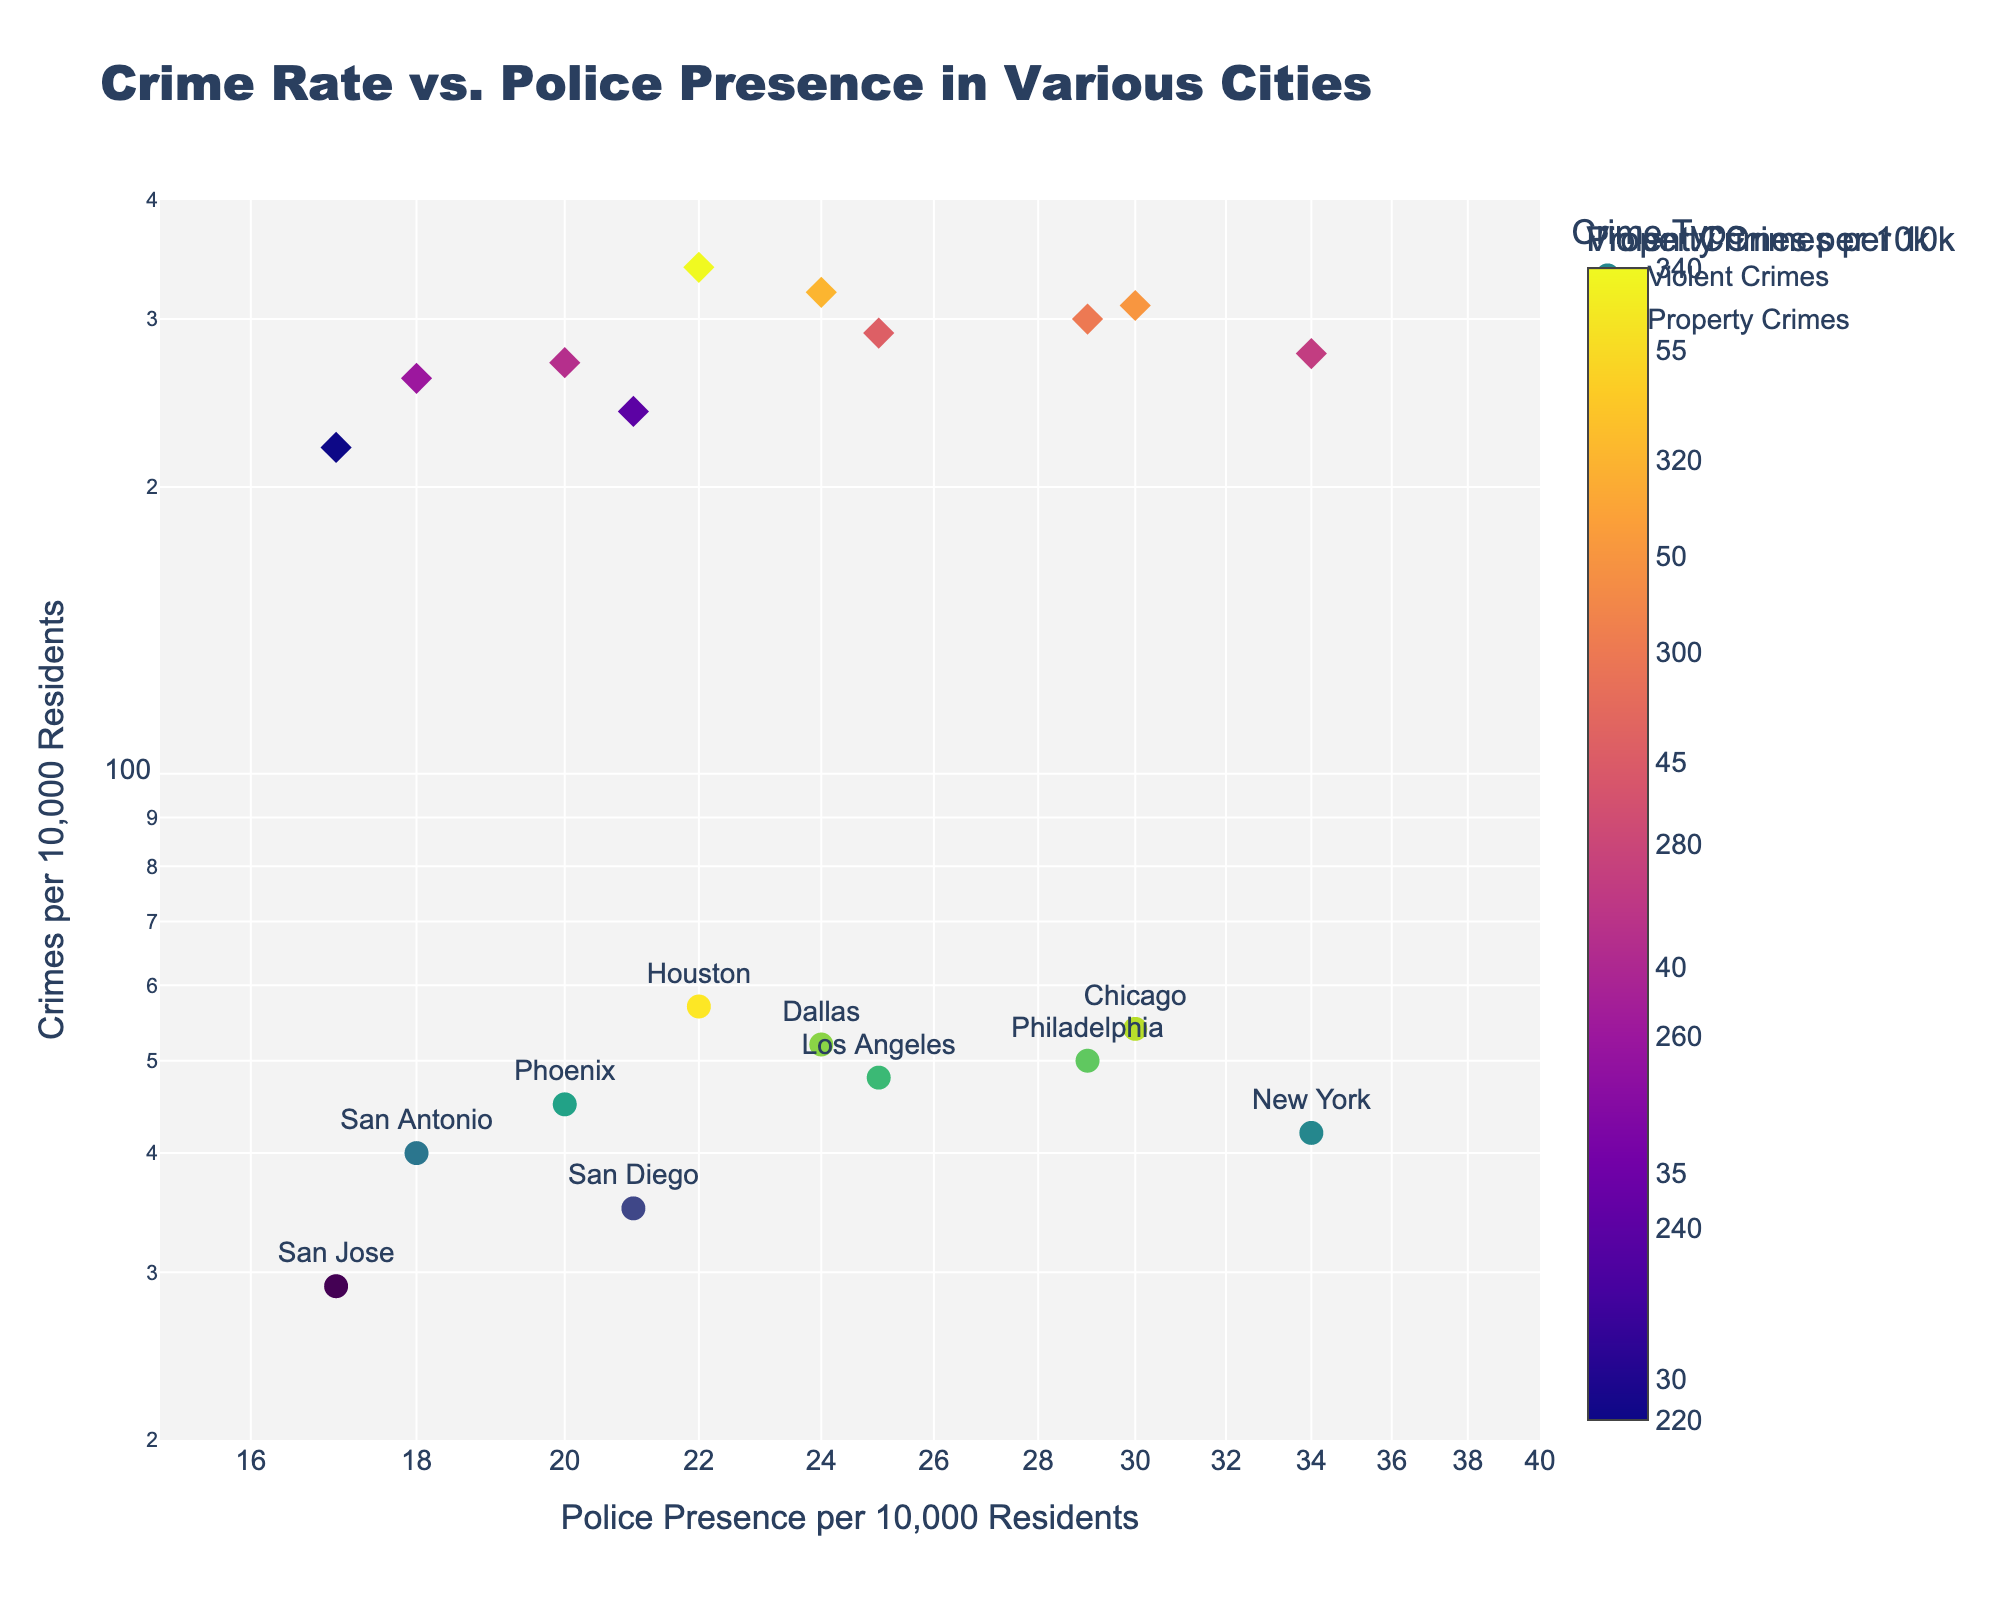What is the title of the figure? The title is usually located at the top of the figure. In this case, the title is 'Crime Rate vs. Police Presence in Various Cities'.
Answer: Crime Rate vs. Police Presence in Various Cities Which city has the highest police presence per 10,000 residents? By looking at the x-axis, New York has the highest value for Police Presence Per 10,000 Residents.
Answer: New York How many cities have police presence between 20 and 25 per 10,000 residents? By checking the x-axis (in log scale) and counting the data points falling between 20 and 25, we see that there are four cities: Phoenix, Houston, Dallas, and Los Angeles.
Answer: 4 Which city has the lowest violent crimes per 10,000 residents? On the y-axis for Violent Crimes Per 10,000 Residents, the city with the lowest data point is San Jose.
Answer: San Jose Is there a city where violent crimes per 10,000 residents are higher than property crimes per 10,000 residents? By comparing the y-values of Violent Crimes and Property Crimes for each city, there is no city where violent crimes are higher than property crimes.
Answer: No What is the general trend of violent crimes as police presence increases? Observing the scatter plot, as Police Presence Per 10,000 Residents increases, Violent Crimes Per 10,000 Residents generally decreases.
Answer: Decreases Which city has the highest property crimes per 10,000 residents? Look at the color intensity and size of the diamond markers for Property Crimes, the city with the highest property crimes per 10,000 is Houston with a value of 340.
Answer: Houston Compare the violent crime rate of Chicago and Dallas. Which city has a higher rate? Finding the markers for Chicago and Dallas on the y-axis for Violent Crimes Per 10,000 Residents, Chicago (54) has a higher violent crime rate than Dallas (52).
Answer: Chicago What is the approximate range of property crimes per 10,000 residents for the cities displayed? The colorbar and y-axis show the range of property crimes, which vary from 220 (San Jose) to 340 (Houston).
Answer: 220 to 340 Which cities are shown to have property crime rates below 250 per 10,000 residents? By looking for lighter-colored diamond markers with lower values on the color scale, San Jose (220), and San Diego (240) have property crime rates below 250 per 10,000 residents.
Answer: San Jose, San Diego 